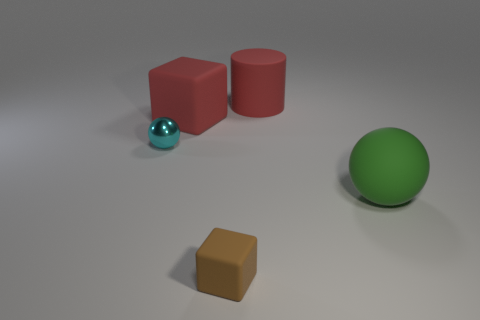Add 3 large brown rubber cylinders. How many objects exist? 8 Subtract 1 cylinders. How many cylinders are left? 0 Subtract all cyan balls. How many balls are left? 1 Subtract all brown cubes. Subtract all red cylinders. How many cubes are left? 1 Subtract all purple cylinders. How many brown blocks are left? 1 Subtract all cyan shiny spheres. Subtract all red matte blocks. How many objects are left? 3 Add 1 green matte objects. How many green matte objects are left? 2 Add 2 cylinders. How many cylinders exist? 3 Subtract 1 red cylinders. How many objects are left? 4 Subtract all blocks. How many objects are left? 3 